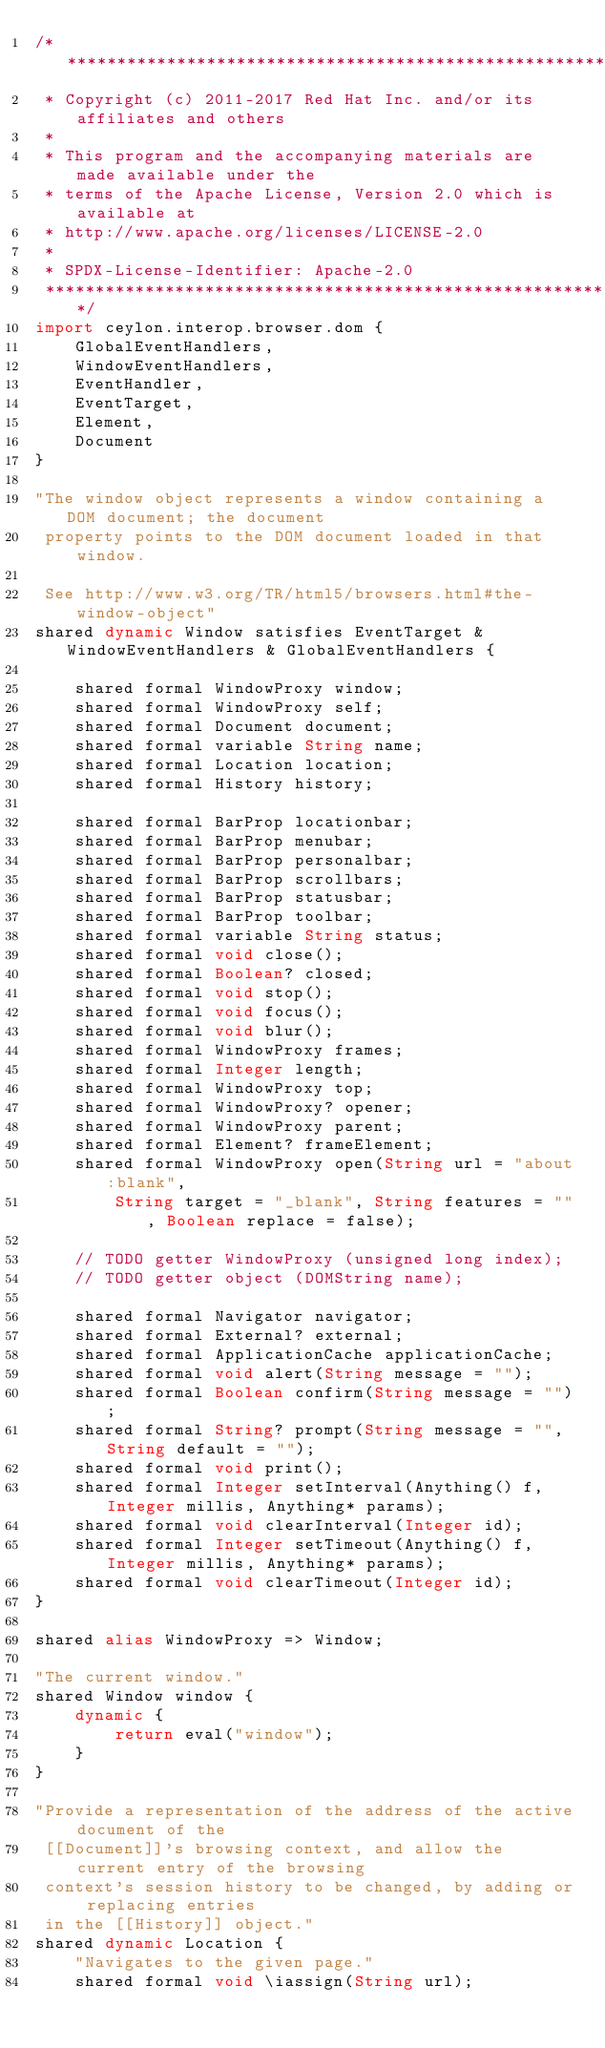Convert code to text. <code><loc_0><loc_0><loc_500><loc_500><_Ceylon_>/********************************************************************************
 * Copyright (c) 2011-2017 Red Hat Inc. and/or its affiliates and others
 *
 * This program and the accompanying materials are made available under the 
 * terms of the Apache License, Version 2.0 which is available at
 * http://www.apache.org/licenses/LICENSE-2.0
 *
 * SPDX-License-Identifier: Apache-2.0 
 ********************************************************************************/
import ceylon.interop.browser.dom {
    GlobalEventHandlers,
    WindowEventHandlers,
    EventHandler,
    EventTarget,
    Element,
    Document
}

"The window object represents a window containing a DOM document; the document
 property points to the DOM document loaded in that window.
 
 See http://www.w3.org/TR/html5/browsers.html#the-window-object"
shared dynamic Window satisfies EventTarget & WindowEventHandlers & GlobalEventHandlers {
    
    shared formal WindowProxy window;
    shared formal WindowProxy self;
    shared formal Document document;
    shared formal variable String name;
    shared formal Location location;
    shared formal History history;
    
    shared formal BarProp locationbar;
    shared formal BarProp menubar;
    shared formal BarProp personalbar;
    shared formal BarProp scrollbars;
    shared formal BarProp statusbar;
    shared formal BarProp toolbar;
    shared formal variable String status;
    shared formal void close();
    shared formal Boolean? closed;
    shared formal void stop();
    shared formal void focus();
    shared formal void blur();
    shared formal WindowProxy frames;
    shared formal Integer length;
    shared formal WindowProxy top;
    shared formal WindowProxy? opener;
    shared formal WindowProxy parent;
    shared formal Element? frameElement;
    shared formal WindowProxy open(String url = "about:blank",
        String target = "_blank", String features = "", Boolean replace = false);
    
    // TODO getter WindowProxy (unsigned long index);
    // TODO getter object (DOMString name);
    
    shared formal Navigator navigator;
    shared formal External? external;
    shared formal ApplicationCache applicationCache;
    shared formal void alert(String message = "");
    shared formal Boolean confirm(String message = "");
    shared formal String? prompt(String message = "", String default = "");
    shared formal void print();
    shared formal Integer setInterval(Anything() f, Integer millis, Anything* params);
    shared formal void clearInterval(Integer id);
    shared formal Integer setTimeout(Anything() f, Integer millis, Anything* params);
    shared formal void clearTimeout(Integer id);
}

shared alias WindowProxy => Window;

"The current window."
shared Window window {
    dynamic {
        return eval("window");
    }
}

"Provide a representation of the address of the active document of the
 [[Document]]'s browsing context, and allow the current entry of the browsing
 context's session history to be changed, by adding or replacing entries
 in the [[History]] object."
shared dynamic Location {
    "Navigates to the given page."
    shared formal void \iassign(String url);
    </code> 